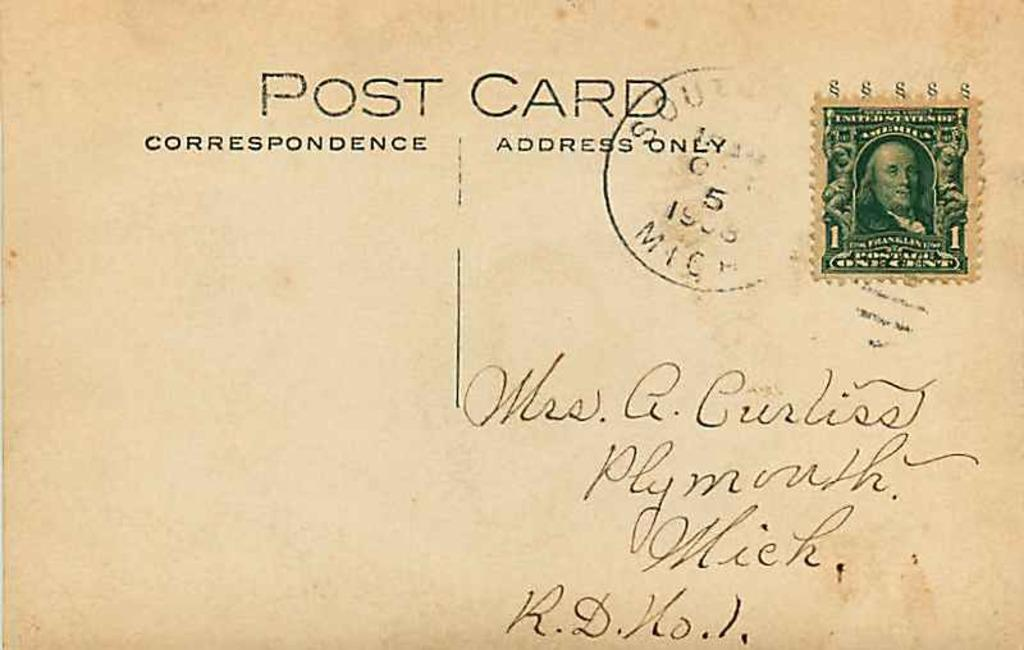Provide a one-sentence caption for the provided image. A post card has been sent to someone for a penny. 